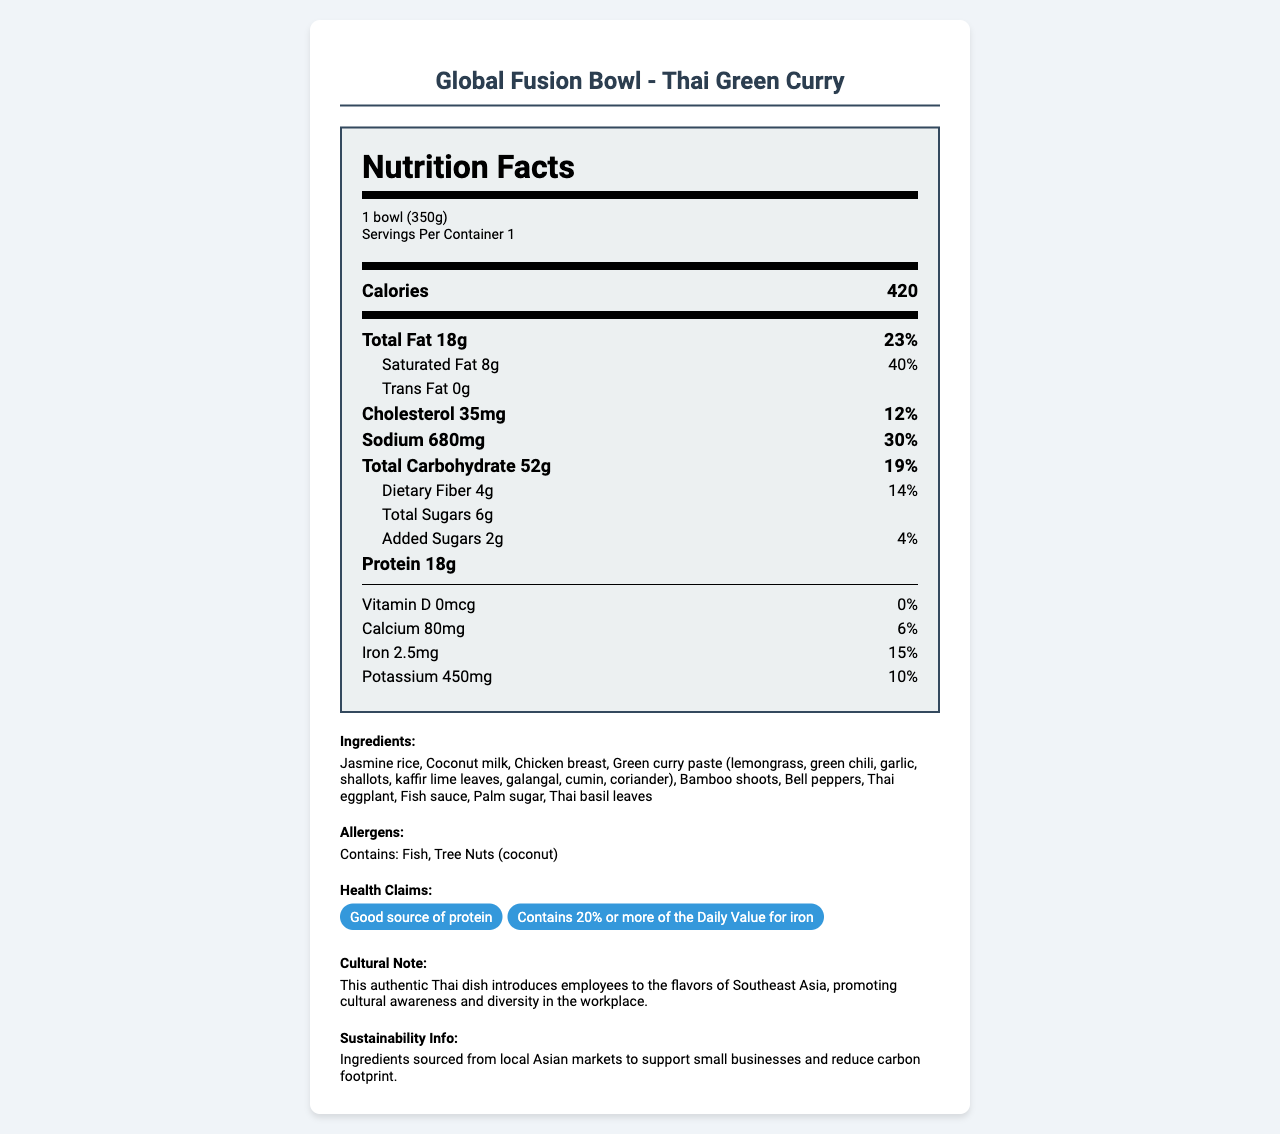what is the serving size? The serving size is specified as "1 bowl (350g)" at the top of the Nutrition Facts.
Answer: 1 bowl (350g) how many calories are in one serving of the Global Fusion Bowl - Thai Green Curry? The calorie content is listed directly in the Nutrition Facts as 420 calories.
Answer: 420 what percentage of the Daily Value does the saturated fat content represent? The saturated fat section specifies an amount of 8g and notes that it represents 40% of the Daily Value.
Answer: 40% how much protein does one serving contain? One serving of the Global Fusion Bowl contains 18g of protein, as listed in the Nutrition Facts.
Answer: 18g which ingredients are used in the Thai Green Curry? The ingredients are listed under the "Ingredients" section.
Answer: Jasmine rice, Coconut milk, Chicken breast, Green curry paste, Bamboo shoots, Bell peppers, Thai eggplant, Fish sauce, Palm sugar, Thai basil leaves which allergens are present in the Global Fusion Bowl - Thai Green Curry? A. Dairy B. Fish C. Peanuts D. Tree Nuts The allergens section specifies "Contains: Fish, Tree Nuts (coconut)".
Answer: B and D what is the sodium content and its Daily Value percentage? The sodium content is listed as 680mg, which is 30% of the Daily Value.
Answer: 680mg, 30% does the dish contain any added sugars? The Nutrition Facts indicate that the dish contains 2g of added sugars which is 4% of the Daily Value.
Answer: Yes how much iron does the dish provide in terms of Daily Value percentage? The iron content is specified as 2.5mg, which is 15% of the Daily Value.
Answer: 15% is the Global Fusion Bowl a good source of protein? The health claims section includes "Good source of protein".
Answer: Yes summarize the main features of the Global Fusion Bowl - Thai Green Curry The summary captures the nutritional content, ingredients, allergens, health benefits, and the cultural and sustainability notes provided in the document.
Answer: The Global Fusion Bowl - Thai Green Curry is a culturally diverse meal option with 420 calories per serving. It contains 18g of protein, 40% Daily Value of saturated fat, and 30% Daily Value of sodium. Ingredients include jasmine rice, coconut milk, and a variety of vegetables and spices. It contains fish and tree nuts as allergens. The dish highlights cultural diversity and supports sustainability by sourcing ingredients from local Asian markets. can the document provide specific information about the supplier of the ingredients? The document mentions that ingredients are sourced from local Asian markets to support small businesses but does not specify the suppliers.
Answer: Not enough information what is the sustainability claim made about the ingredients? The sustainability information section provides this detail.
Answer: Ingredients are sourced from local Asian markets to support small businesses and reduce carbon footprint does the dish contain any trans fat? The Nutrition Facts specify that the trans fat content is 0g.
Answer: No 